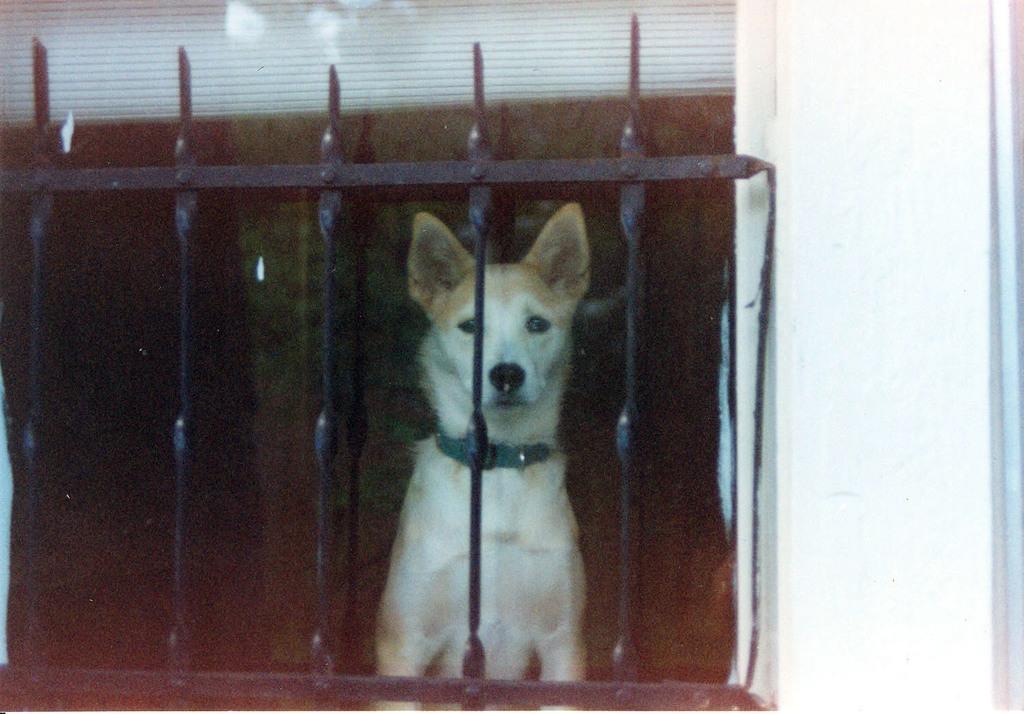Can you describe this image briefly? In this picture we can observe and dog sitting behind the black color railing. The dog is in white and brown color. We can observe a white color wall on the right side. 